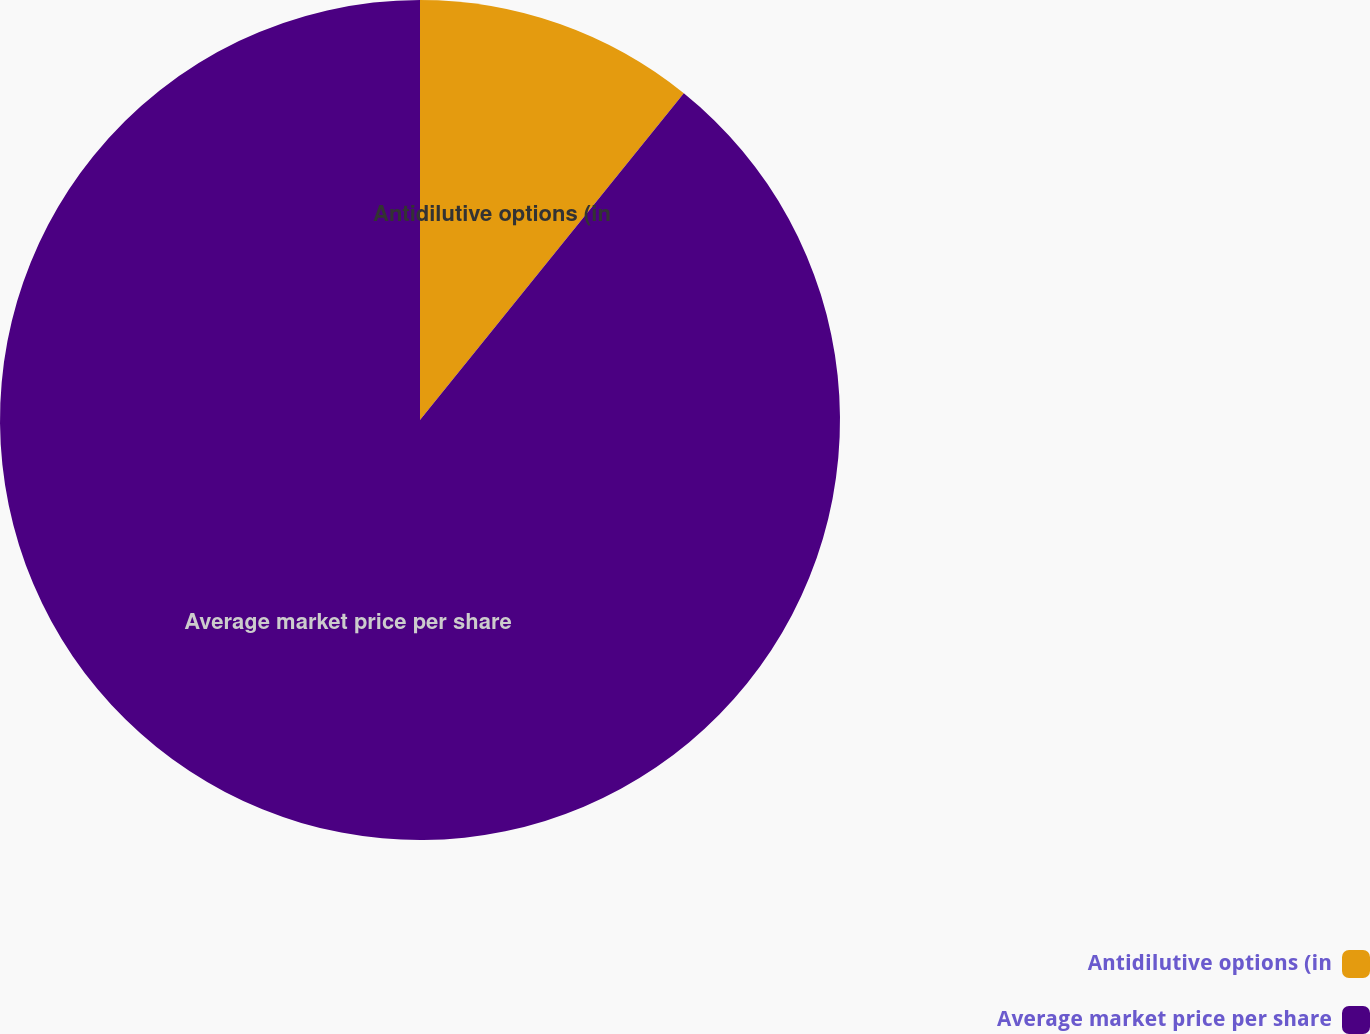Convert chart. <chart><loc_0><loc_0><loc_500><loc_500><pie_chart><fcel>Antidilutive options (in<fcel>Average market price per share<nl><fcel>10.81%<fcel>89.19%<nl></chart> 